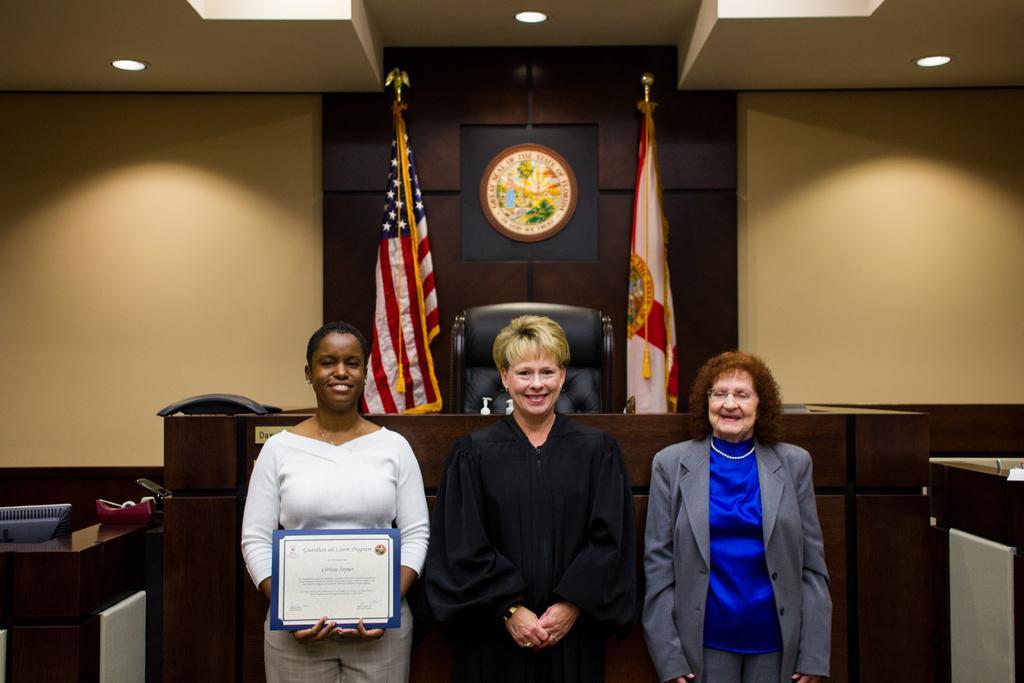How would you summarize this image in a sentence or two? In this image I see 3 women who are smiling and this woman is holding a white and blue color thing in her hands. In the background I see the wall and I see the flags which are colorful and I see the lights on the ceiling and I see the logo over here. 